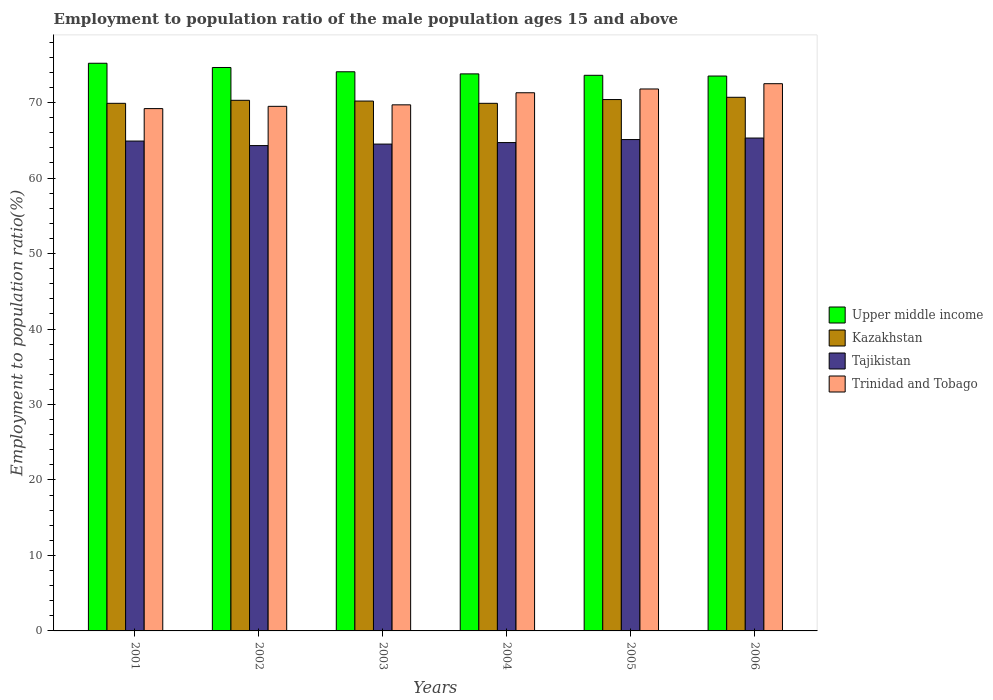How many bars are there on the 1st tick from the left?
Offer a terse response. 4. How many bars are there on the 5th tick from the right?
Your response must be concise. 4. What is the employment to population ratio in Tajikistan in 2001?
Give a very brief answer. 64.9. Across all years, what is the maximum employment to population ratio in Trinidad and Tobago?
Provide a short and direct response. 72.5. Across all years, what is the minimum employment to population ratio in Kazakhstan?
Your answer should be very brief. 69.9. What is the total employment to population ratio in Kazakhstan in the graph?
Keep it short and to the point. 421.4. What is the difference between the employment to population ratio in Upper middle income in 2002 and that in 2006?
Your response must be concise. 1.13. What is the difference between the employment to population ratio in Trinidad and Tobago in 2005 and the employment to population ratio in Upper middle income in 2001?
Ensure brevity in your answer.  -3.41. What is the average employment to population ratio in Tajikistan per year?
Your response must be concise. 64.8. In the year 2003, what is the difference between the employment to population ratio in Tajikistan and employment to population ratio in Trinidad and Tobago?
Offer a terse response. -5.2. In how many years, is the employment to population ratio in Upper middle income greater than 4 %?
Your answer should be very brief. 6. What is the ratio of the employment to population ratio in Upper middle income in 2005 to that in 2006?
Offer a terse response. 1. Is the employment to population ratio in Kazakhstan in 2004 less than that in 2006?
Offer a very short reply. Yes. What is the difference between the highest and the second highest employment to population ratio in Trinidad and Tobago?
Offer a very short reply. 0.7. What is the difference between the highest and the lowest employment to population ratio in Upper middle income?
Keep it short and to the point. 1.69. In how many years, is the employment to population ratio in Kazakhstan greater than the average employment to population ratio in Kazakhstan taken over all years?
Provide a short and direct response. 3. Is the sum of the employment to population ratio in Trinidad and Tobago in 2001 and 2004 greater than the maximum employment to population ratio in Tajikistan across all years?
Provide a short and direct response. Yes. What does the 3rd bar from the left in 2001 represents?
Your answer should be compact. Tajikistan. What does the 4th bar from the right in 2006 represents?
Make the answer very short. Upper middle income. Is it the case that in every year, the sum of the employment to population ratio in Upper middle income and employment to population ratio in Trinidad and Tobago is greater than the employment to population ratio in Kazakhstan?
Ensure brevity in your answer.  Yes. What is the difference between two consecutive major ticks on the Y-axis?
Your answer should be compact. 10. Are the values on the major ticks of Y-axis written in scientific E-notation?
Keep it short and to the point. No. Does the graph contain grids?
Provide a succinct answer. No. Where does the legend appear in the graph?
Ensure brevity in your answer.  Center right. What is the title of the graph?
Ensure brevity in your answer.  Employment to population ratio of the male population ages 15 and above. What is the label or title of the X-axis?
Provide a short and direct response. Years. What is the Employment to population ratio(%) of Upper middle income in 2001?
Provide a succinct answer. 75.21. What is the Employment to population ratio(%) in Kazakhstan in 2001?
Give a very brief answer. 69.9. What is the Employment to population ratio(%) of Tajikistan in 2001?
Make the answer very short. 64.9. What is the Employment to population ratio(%) of Trinidad and Tobago in 2001?
Offer a very short reply. 69.2. What is the Employment to population ratio(%) of Upper middle income in 2002?
Offer a terse response. 74.65. What is the Employment to population ratio(%) in Kazakhstan in 2002?
Make the answer very short. 70.3. What is the Employment to population ratio(%) of Tajikistan in 2002?
Your response must be concise. 64.3. What is the Employment to population ratio(%) of Trinidad and Tobago in 2002?
Give a very brief answer. 69.5. What is the Employment to population ratio(%) of Upper middle income in 2003?
Your response must be concise. 74.08. What is the Employment to population ratio(%) of Kazakhstan in 2003?
Your response must be concise. 70.2. What is the Employment to population ratio(%) in Tajikistan in 2003?
Make the answer very short. 64.5. What is the Employment to population ratio(%) in Trinidad and Tobago in 2003?
Your answer should be compact. 69.7. What is the Employment to population ratio(%) in Upper middle income in 2004?
Provide a short and direct response. 73.8. What is the Employment to population ratio(%) in Kazakhstan in 2004?
Your answer should be compact. 69.9. What is the Employment to population ratio(%) in Tajikistan in 2004?
Offer a terse response. 64.7. What is the Employment to population ratio(%) in Trinidad and Tobago in 2004?
Offer a terse response. 71.3. What is the Employment to population ratio(%) in Upper middle income in 2005?
Offer a very short reply. 73.61. What is the Employment to population ratio(%) of Kazakhstan in 2005?
Keep it short and to the point. 70.4. What is the Employment to population ratio(%) of Tajikistan in 2005?
Your answer should be compact. 65.1. What is the Employment to population ratio(%) in Trinidad and Tobago in 2005?
Provide a succinct answer. 71.8. What is the Employment to population ratio(%) in Upper middle income in 2006?
Ensure brevity in your answer.  73.51. What is the Employment to population ratio(%) in Kazakhstan in 2006?
Offer a terse response. 70.7. What is the Employment to population ratio(%) in Tajikistan in 2006?
Ensure brevity in your answer.  65.3. What is the Employment to population ratio(%) of Trinidad and Tobago in 2006?
Keep it short and to the point. 72.5. Across all years, what is the maximum Employment to population ratio(%) in Upper middle income?
Provide a short and direct response. 75.21. Across all years, what is the maximum Employment to population ratio(%) in Kazakhstan?
Keep it short and to the point. 70.7. Across all years, what is the maximum Employment to population ratio(%) in Tajikistan?
Your answer should be compact. 65.3. Across all years, what is the maximum Employment to population ratio(%) of Trinidad and Tobago?
Offer a very short reply. 72.5. Across all years, what is the minimum Employment to population ratio(%) in Upper middle income?
Offer a terse response. 73.51. Across all years, what is the minimum Employment to population ratio(%) of Kazakhstan?
Make the answer very short. 69.9. Across all years, what is the minimum Employment to population ratio(%) of Tajikistan?
Your response must be concise. 64.3. Across all years, what is the minimum Employment to population ratio(%) in Trinidad and Tobago?
Provide a short and direct response. 69.2. What is the total Employment to population ratio(%) of Upper middle income in the graph?
Provide a short and direct response. 444.86. What is the total Employment to population ratio(%) in Kazakhstan in the graph?
Make the answer very short. 421.4. What is the total Employment to population ratio(%) of Tajikistan in the graph?
Keep it short and to the point. 388.8. What is the total Employment to population ratio(%) in Trinidad and Tobago in the graph?
Offer a terse response. 424. What is the difference between the Employment to population ratio(%) of Upper middle income in 2001 and that in 2002?
Your answer should be very brief. 0.56. What is the difference between the Employment to population ratio(%) of Kazakhstan in 2001 and that in 2002?
Ensure brevity in your answer.  -0.4. What is the difference between the Employment to population ratio(%) in Trinidad and Tobago in 2001 and that in 2002?
Give a very brief answer. -0.3. What is the difference between the Employment to population ratio(%) in Upper middle income in 2001 and that in 2003?
Offer a very short reply. 1.13. What is the difference between the Employment to population ratio(%) of Trinidad and Tobago in 2001 and that in 2003?
Your answer should be compact. -0.5. What is the difference between the Employment to population ratio(%) in Upper middle income in 2001 and that in 2004?
Make the answer very short. 1.41. What is the difference between the Employment to population ratio(%) of Tajikistan in 2001 and that in 2004?
Offer a terse response. 0.2. What is the difference between the Employment to population ratio(%) in Upper middle income in 2001 and that in 2005?
Provide a succinct answer. 1.6. What is the difference between the Employment to population ratio(%) in Trinidad and Tobago in 2001 and that in 2005?
Offer a very short reply. -2.6. What is the difference between the Employment to population ratio(%) of Upper middle income in 2001 and that in 2006?
Your answer should be compact. 1.69. What is the difference between the Employment to population ratio(%) of Kazakhstan in 2001 and that in 2006?
Keep it short and to the point. -0.8. What is the difference between the Employment to population ratio(%) in Tajikistan in 2001 and that in 2006?
Ensure brevity in your answer.  -0.4. What is the difference between the Employment to population ratio(%) of Upper middle income in 2002 and that in 2003?
Give a very brief answer. 0.57. What is the difference between the Employment to population ratio(%) in Tajikistan in 2002 and that in 2003?
Provide a short and direct response. -0.2. What is the difference between the Employment to population ratio(%) of Trinidad and Tobago in 2002 and that in 2003?
Provide a short and direct response. -0.2. What is the difference between the Employment to population ratio(%) in Upper middle income in 2002 and that in 2004?
Your response must be concise. 0.85. What is the difference between the Employment to population ratio(%) of Kazakhstan in 2002 and that in 2004?
Make the answer very short. 0.4. What is the difference between the Employment to population ratio(%) of Tajikistan in 2002 and that in 2004?
Your answer should be compact. -0.4. What is the difference between the Employment to population ratio(%) of Upper middle income in 2002 and that in 2005?
Offer a terse response. 1.04. What is the difference between the Employment to population ratio(%) of Kazakhstan in 2002 and that in 2005?
Your answer should be very brief. -0.1. What is the difference between the Employment to population ratio(%) in Upper middle income in 2002 and that in 2006?
Make the answer very short. 1.13. What is the difference between the Employment to population ratio(%) in Kazakhstan in 2002 and that in 2006?
Keep it short and to the point. -0.4. What is the difference between the Employment to population ratio(%) of Tajikistan in 2002 and that in 2006?
Make the answer very short. -1. What is the difference between the Employment to population ratio(%) in Upper middle income in 2003 and that in 2004?
Your answer should be compact. 0.28. What is the difference between the Employment to population ratio(%) of Trinidad and Tobago in 2003 and that in 2004?
Your answer should be compact. -1.6. What is the difference between the Employment to population ratio(%) of Upper middle income in 2003 and that in 2005?
Give a very brief answer. 0.47. What is the difference between the Employment to population ratio(%) in Tajikistan in 2003 and that in 2005?
Provide a succinct answer. -0.6. What is the difference between the Employment to population ratio(%) of Trinidad and Tobago in 2003 and that in 2005?
Offer a very short reply. -2.1. What is the difference between the Employment to population ratio(%) of Upper middle income in 2003 and that in 2006?
Make the answer very short. 0.56. What is the difference between the Employment to population ratio(%) in Kazakhstan in 2003 and that in 2006?
Provide a short and direct response. -0.5. What is the difference between the Employment to population ratio(%) in Tajikistan in 2003 and that in 2006?
Your answer should be compact. -0.8. What is the difference between the Employment to population ratio(%) in Upper middle income in 2004 and that in 2005?
Keep it short and to the point. 0.19. What is the difference between the Employment to population ratio(%) of Trinidad and Tobago in 2004 and that in 2005?
Provide a succinct answer. -0.5. What is the difference between the Employment to population ratio(%) in Upper middle income in 2004 and that in 2006?
Provide a succinct answer. 0.28. What is the difference between the Employment to population ratio(%) of Upper middle income in 2005 and that in 2006?
Provide a succinct answer. 0.1. What is the difference between the Employment to population ratio(%) in Upper middle income in 2001 and the Employment to population ratio(%) in Kazakhstan in 2002?
Offer a terse response. 4.91. What is the difference between the Employment to population ratio(%) of Upper middle income in 2001 and the Employment to population ratio(%) of Tajikistan in 2002?
Offer a terse response. 10.91. What is the difference between the Employment to population ratio(%) in Upper middle income in 2001 and the Employment to population ratio(%) in Trinidad and Tobago in 2002?
Your response must be concise. 5.71. What is the difference between the Employment to population ratio(%) in Kazakhstan in 2001 and the Employment to population ratio(%) in Tajikistan in 2002?
Keep it short and to the point. 5.6. What is the difference between the Employment to population ratio(%) in Upper middle income in 2001 and the Employment to population ratio(%) in Kazakhstan in 2003?
Offer a terse response. 5.01. What is the difference between the Employment to population ratio(%) in Upper middle income in 2001 and the Employment to population ratio(%) in Tajikistan in 2003?
Your answer should be very brief. 10.71. What is the difference between the Employment to population ratio(%) of Upper middle income in 2001 and the Employment to population ratio(%) of Trinidad and Tobago in 2003?
Your answer should be compact. 5.51. What is the difference between the Employment to population ratio(%) in Kazakhstan in 2001 and the Employment to population ratio(%) in Tajikistan in 2003?
Your answer should be compact. 5.4. What is the difference between the Employment to population ratio(%) of Kazakhstan in 2001 and the Employment to population ratio(%) of Trinidad and Tobago in 2003?
Give a very brief answer. 0.2. What is the difference between the Employment to population ratio(%) in Upper middle income in 2001 and the Employment to population ratio(%) in Kazakhstan in 2004?
Provide a short and direct response. 5.31. What is the difference between the Employment to population ratio(%) of Upper middle income in 2001 and the Employment to population ratio(%) of Tajikistan in 2004?
Give a very brief answer. 10.51. What is the difference between the Employment to population ratio(%) of Upper middle income in 2001 and the Employment to population ratio(%) of Trinidad and Tobago in 2004?
Provide a succinct answer. 3.91. What is the difference between the Employment to population ratio(%) in Kazakhstan in 2001 and the Employment to population ratio(%) in Tajikistan in 2004?
Ensure brevity in your answer.  5.2. What is the difference between the Employment to population ratio(%) in Kazakhstan in 2001 and the Employment to population ratio(%) in Trinidad and Tobago in 2004?
Make the answer very short. -1.4. What is the difference between the Employment to population ratio(%) of Tajikistan in 2001 and the Employment to population ratio(%) of Trinidad and Tobago in 2004?
Make the answer very short. -6.4. What is the difference between the Employment to population ratio(%) of Upper middle income in 2001 and the Employment to population ratio(%) of Kazakhstan in 2005?
Provide a succinct answer. 4.81. What is the difference between the Employment to population ratio(%) in Upper middle income in 2001 and the Employment to population ratio(%) in Tajikistan in 2005?
Offer a very short reply. 10.11. What is the difference between the Employment to population ratio(%) of Upper middle income in 2001 and the Employment to population ratio(%) of Trinidad and Tobago in 2005?
Your answer should be very brief. 3.41. What is the difference between the Employment to population ratio(%) in Kazakhstan in 2001 and the Employment to population ratio(%) in Tajikistan in 2005?
Give a very brief answer. 4.8. What is the difference between the Employment to population ratio(%) in Kazakhstan in 2001 and the Employment to population ratio(%) in Trinidad and Tobago in 2005?
Make the answer very short. -1.9. What is the difference between the Employment to population ratio(%) in Tajikistan in 2001 and the Employment to population ratio(%) in Trinidad and Tobago in 2005?
Your response must be concise. -6.9. What is the difference between the Employment to population ratio(%) in Upper middle income in 2001 and the Employment to population ratio(%) in Kazakhstan in 2006?
Offer a terse response. 4.51. What is the difference between the Employment to population ratio(%) in Upper middle income in 2001 and the Employment to population ratio(%) in Tajikistan in 2006?
Give a very brief answer. 9.91. What is the difference between the Employment to population ratio(%) in Upper middle income in 2001 and the Employment to population ratio(%) in Trinidad and Tobago in 2006?
Provide a short and direct response. 2.71. What is the difference between the Employment to population ratio(%) of Upper middle income in 2002 and the Employment to population ratio(%) of Kazakhstan in 2003?
Offer a very short reply. 4.45. What is the difference between the Employment to population ratio(%) of Upper middle income in 2002 and the Employment to population ratio(%) of Tajikistan in 2003?
Your answer should be compact. 10.15. What is the difference between the Employment to population ratio(%) of Upper middle income in 2002 and the Employment to population ratio(%) of Trinidad and Tobago in 2003?
Give a very brief answer. 4.95. What is the difference between the Employment to population ratio(%) of Kazakhstan in 2002 and the Employment to population ratio(%) of Tajikistan in 2003?
Keep it short and to the point. 5.8. What is the difference between the Employment to population ratio(%) of Kazakhstan in 2002 and the Employment to population ratio(%) of Trinidad and Tobago in 2003?
Offer a very short reply. 0.6. What is the difference between the Employment to population ratio(%) of Upper middle income in 2002 and the Employment to population ratio(%) of Kazakhstan in 2004?
Your answer should be compact. 4.75. What is the difference between the Employment to population ratio(%) in Upper middle income in 2002 and the Employment to population ratio(%) in Tajikistan in 2004?
Provide a short and direct response. 9.95. What is the difference between the Employment to population ratio(%) of Upper middle income in 2002 and the Employment to population ratio(%) of Trinidad and Tobago in 2004?
Offer a very short reply. 3.35. What is the difference between the Employment to population ratio(%) of Kazakhstan in 2002 and the Employment to population ratio(%) of Tajikistan in 2004?
Offer a very short reply. 5.6. What is the difference between the Employment to population ratio(%) in Kazakhstan in 2002 and the Employment to population ratio(%) in Trinidad and Tobago in 2004?
Give a very brief answer. -1. What is the difference between the Employment to population ratio(%) in Tajikistan in 2002 and the Employment to population ratio(%) in Trinidad and Tobago in 2004?
Make the answer very short. -7. What is the difference between the Employment to population ratio(%) in Upper middle income in 2002 and the Employment to population ratio(%) in Kazakhstan in 2005?
Your response must be concise. 4.25. What is the difference between the Employment to population ratio(%) of Upper middle income in 2002 and the Employment to population ratio(%) of Tajikistan in 2005?
Keep it short and to the point. 9.55. What is the difference between the Employment to population ratio(%) of Upper middle income in 2002 and the Employment to population ratio(%) of Trinidad and Tobago in 2005?
Keep it short and to the point. 2.85. What is the difference between the Employment to population ratio(%) of Tajikistan in 2002 and the Employment to population ratio(%) of Trinidad and Tobago in 2005?
Offer a terse response. -7.5. What is the difference between the Employment to population ratio(%) in Upper middle income in 2002 and the Employment to population ratio(%) in Kazakhstan in 2006?
Ensure brevity in your answer.  3.95. What is the difference between the Employment to population ratio(%) of Upper middle income in 2002 and the Employment to population ratio(%) of Tajikistan in 2006?
Your response must be concise. 9.35. What is the difference between the Employment to population ratio(%) of Upper middle income in 2002 and the Employment to population ratio(%) of Trinidad and Tobago in 2006?
Provide a short and direct response. 2.15. What is the difference between the Employment to population ratio(%) of Kazakhstan in 2002 and the Employment to population ratio(%) of Tajikistan in 2006?
Give a very brief answer. 5. What is the difference between the Employment to population ratio(%) of Kazakhstan in 2002 and the Employment to population ratio(%) of Trinidad and Tobago in 2006?
Your answer should be very brief. -2.2. What is the difference between the Employment to population ratio(%) of Upper middle income in 2003 and the Employment to population ratio(%) of Kazakhstan in 2004?
Ensure brevity in your answer.  4.18. What is the difference between the Employment to population ratio(%) in Upper middle income in 2003 and the Employment to population ratio(%) in Tajikistan in 2004?
Your response must be concise. 9.38. What is the difference between the Employment to population ratio(%) in Upper middle income in 2003 and the Employment to population ratio(%) in Trinidad and Tobago in 2004?
Your answer should be compact. 2.78. What is the difference between the Employment to population ratio(%) of Upper middle income in 2003 and the Employment to population ratio(%) of Kazakhstan in 2005?
Ensure brevity in your answer.  3.68. What is the difference between the Employment to population ratio(%) in Upper middle income in 2003 and the Employment to population ratio(%) in Tajikistan in 2005?
Ensure brevity in your answer.  8.98. What is the difference between the Employment to population ratio(%) in Upper middle income in 2003 and the Employment to population ratio(%) in Trinidad and Tobago in 2005?
Your answer should be very brief. 2.28. What is the difference between the Employment to population ratio(%) of Upper middle income in 2003 and the Employment to population ratio(%) of Kazakhstan in 2006?
Your response must be concise. 3.38. What is the difference between the Employment to population ratio(%) of Upper middle income in 2003 and the Employment to population ratio(%) of Tajikistan in 2006?
Offer a very short reply. 8.78. What is the difference between the Employment to population ratio(%) of Upper middle income in 2003 and the Employment to population ratio(%) of Trinidad and Tobago in 2006?
Your response must be concise. 1.58. What is the difference between the Employment to population ratio(%) of Kazakhstan in 2003 and the Employment to population ratio(%) of Tajikistan in 2006?
Keep it short and to the point. 4.9. What is the difference between the Employment to population ratio(%) of Upper middle income in 2004 and the Employment to population ratio(%) of Kazakhstan in 2005?
Your response must be concise. 3.4. What is the difference between the Employment to population ratio(%) in Upper middle income in 2004 and the Employment to population ratio(%) in Tajikistan in 2005?
Your answer should be compact. 8.7. What is the difference between the Employment to population ratio(%) of Upper middle income in 2004 and the Employment to population ratio(%) of Trinidad and Tobago in 2005?
Provide a succinct answer. 2. What is the difference between the Employment to population ratio(%) in Kazakhstan in 2004 and the Employment to population ratio(%) in Trinidad and Tobago in 2005?
Ensure brevity in your answer.  -1.9. What is the difference between the Employment to population ratio(%) of Tajikistan in 2004 and the Employment to population ratio(%) of Trinidad and Tobago in 2005?
Your answer should be compact. -7.1. What is the difference between the Employment to population ratio(%) in Upper middle income in 2004 and the Employment to population ratio(%) in Kazakhstan in 2006?
Provide a short and direct response. 3.1. What is the difference between the Employment to population ratio(%) in Upper middle income in 2004 and the Employment to population ratio(%) in Tajikistan in 2006?
Ensure brevity in your answer.  8.5. What is the difference between the Employment to population ratio(%) of Upper middle income in 2004 and the Employment to population ratio(%) of Trinidad and Tobago in 2006?
Keep it short and to the point. 1.3. What is the difference between the Employment to population ratio(%) of Tajikistan in 2004 and the Employment to population ratio(%) of Trinidad and Tobago in 2006?
Offer a very short reply. -7.8. What is the difference between the Employment to population ratio(%) in Upper middle income in 2005 and the Employment to population ratio(%) in Kazakhstan in 2006?
Keep it short and to the point. 2.91. What is the difference between the Employment to population ratio(%) of Upper middle income in 2005 and the Employment to population ratio(%) of Tajikistan in 2006?
Ensure brevity in your answer.  8.31. What is the difference between the Employment to population ratio(%) in Upper middle income in 2005 and the Employment to population ratio(%) in Trinidad and Tobago in 2006?
Keep it short and to the point. 1.11. What is the difference between the Employment to population ratio(%) of Kazakhstan in 2005 and the Employment to population ratio(%) of Tajikistan in 2006?
Give a very brief answer. 5.1. What is the difference between the Employment to population ratio(%) of Tajikistan in 2005 and the Employment to population ratio(%) of Trinidad and Tobago in 2006?
Your response must be concise. -7.4. What is the average Employment to population ratio(%) in Upper middle income per year?
Offer a terse response. 74.14. What is the average Employment to population ratio(%) in Kazakhstan per year?
Offer a very short reply. 70.23. What is the average Employment to population ratio(%) of Tajikistan per year?
Ensure brevity in your answer.  64.8. What is the average Employment to population ratio(%) of Trinidad and Tobago per year?
Your answer should be very brief. 70.67. In the year 2001, what is the difference between the Employment to population ratio(%) in Upper middle income and Employment to population ratio(%) in Kazakhstan?
Provide a succinct answer. 5.31. In the year 2001, what is the difference between the Employment to population ratio(%) of Upper middle income and Employment to population ratio(%) of Tajikistan?
Provide a succinct answer. 10.31. In the year 2001, what is the difference between the Employment to population ratio(%) in Upper middle income and Employment to population ratio(%) in Trinidad and Tobago?
Give a very brief answer. 6.01. In the year 2001, what is the difference between the Employment to population ratio(%) in Kazakhstan and Employment to population ratio(%) in Tajikistan?
Provide a short and direct response. 5. In the year 2001, what is the difference between the Employment to population ratio(%) in Kazakhstan and Employment to population ratio(%) in Trinidad and Tobago?
Ensure brevity in your answer.  0.7. In the year 2001, what is the difference between the Employment to population ratio(%) of Tajikistan and Employment to population ratio(%) of Trinidad and Tobago?
Provide a short and direct response. -4.3. In the year 2002, what is the difference between the Employment to population ratio(%) in Upper middle income and Employment to population ratio(%) in Kazakhstan?
Give a very brief answer. 4.35. In the year 2002, what is the difference between the Employment to population ratio(%) of Upper middle income and Employment to population ratio(%) of Tajikistan?
Keep it short and to the point. 10.35. In the year 2002, what is the difference between the Employment to population ratio(%) in Upper middle income and Employment to population ratio(%) in Trinidad and Tobago?
Provide a short and direct response. 5.15. In the year 2002, what is the difference between the Employment to population ratio(%) of Kazakhstan and Employment to population ratio(%) of Tajikistan?
Ensure brevity in your answer.  6. In the year 2002, what is the difference between the Employment to population ratio(%) of Kazakhstan and Employment to population ratio(%) of Trinidad and Tobago?
Your response must be concise. 0.8. In the year 2002, what is the difference between the Employment to population ratio(%) of Tajikistan and Employment to population ratio(%) of Trinidad and Tobago?
Your answer should be compact. -5.2. In the year 2003, what is the difference between the Employment to population ratio(%) of Upper middle income and Employment to population ratio(%) of Kazakhstan?
Offer a very short reply. 3.88. In the year 2003, what is the difference between the Employment to population ratio(%) in Upper middle income and Employment to population ratio(%) in Tajikistan?
Keep it short and to the point. 9.58. In the year 2003, what is the difference between the Employment to population ratio(%) in Upper middle income and Employment to population ratio(%) in Trinidad and Tobago?
Provide a short and direct response. 4.38. In the year 2003, what is the difference between the Employment to population ratio(%) in Kazakhstan and Employment to population ratio(%) in Tajikistan?
Offer a very short reply. 5.7. In the year 2003, what is the difference between the Employment to population ratio(%) in Kazakhstan and Employment to population ratio(%) in Trinidad and Tobago?
Keep it short and to the point. 0.5. In the year 2004, what is the difference between the Employment to population ratio(%) in Upper middle income and Employment to population ratio(%) in Kazakhstan?
Make the answer very short. 3.9. In the year 2004, what is the difference between the Employment to population ratio(%) of Upper middle income and Employment to population ratio(%) of Tajikistan?
Your response must be concise. 9.1. In the year 2004, what is the difference between the Employment to population ratio(%) of Upper middle income and Employment to population ratio(%) of Trinidad and Tobago?
Ensure brevity in your answer.  2.5. In the year 2004, what is the difference between the Employment to population ratio(%) of Kazakhstan and Employment to population ratio(%) of Tajikistan?
Provide a succinct answer. 5.2. In the year 2004, what is the difference between the Employment to population ratio(%) in Kazakhstan and Employment to population ratio(%) in Trinidad and Tobago?
Ensure brevity in your answer.  -1.4. In the year 2005, what is the difference between the Employment to population ratio(%) of Upper middle income and Employment to population ratio(%) of Kazakhstan?
Ensure brevity in your answer.  3.21. In the year 2005, what is the difference between the Employment to population ratio(%) of Upper middle income and Employment to population ratio(%) of Tajikistan?
Your answer should be compact. 8.51. In the year 2005, what is the difference between the Employment to population ratio(%) in Upper middle income and Employment to population ratio(%) in Trinidad and Tobago?
Offer a terse response. 1.81. In the year 2005, what is the difference between the Employment to population ratio(%) of Kazakhstan and Employment to population ratio(%) of Tajikistan?
Give a very brief answer. 5.3. In the year 2005, what is the difference between the Employment to population ratio(%) of Tajikistan and Employment to population ratio(%) of Trinidad and Tobago?
Offer a very short reply. -6.7. In the year 2006, what is the difference between the Employment to population ratio(%) in Upper middle income and Employment to population ratio(%) in Kazakhstan?
Provide a short and direct response. 2.81. In the year 2006, what is the difference between the Employment to population ratio(%) of Upper middle income and Employment to population ratio(%) of Tajikistan?
Make the answer very short. 8.21. In the year 2006, what is the difference between the Employment to population ratio(%) of Upper middle income and Employment to population ratio(%) of Trinidad and Tobago?
Offer a very short reply. 1.01. In the year 2006, what is the difference between the Employment to population ratio(%) in Kazakhstan and Employment to population ratio(%) in Trinidad and Tobago?
Your answer should be compact. -1.8. What is the ratio of the Employment to population ratio(%) in Upper middle income in 2001 to that in 2002?
Ensure brevity in your answer.  1.01. What is the ratio of the Employment to population ratio(%) in Tajikistan in 2001 to that in 2002?
Give a very brief answer. 1.01. What is the ratio of the Employment to population ratio(%) in Trinidad and Tobago in 2001 to that in 2002?
Your answer should be compact. 1. What is the ratio of the Employment to population ratio(%) in Upper middle income in 2001 to that in 2003?
Make the answer very short. 1.02. What is the ratio of the Employment to population ratio(%) in Kazakhstan in 2001 to that in 2003?
Give a very brief answer. 1. What is the ratio of the Employment to population ratio(%) in Tajikistan in 2001 to that in 2003?
Give a very brief answer. 1.01. What is the ratio of the Employment to population ratio(%) in Trinidad and Tobago in 2001 to that in 2003?
Your answer should be compact. 0.99. What is the ratio of the Employment to population ratio(%) in Upper middle income in 2001 to that in 2004?
Make the answer very short. 1.02. What is the ratio of the Employment to population ratio(%) of Kazakhstan in 2001 to that in 2004?
Your response must be concise. 1. What is the ratio of the Employment to population ratio(%) of Trinidad and Tobago in 2001 to that in 2004?
Offer a terse response. 0.97. What is the ratio of the Employment to population ratio(%) of Upper middle income in 2001 to that in 2005?
Provide a succinct answer. 1.02. What is the ratio of the Employment to population ratio(%) of Trinidad and Tobago in 2001 to that in 2005?
Ensure brevity in your answer.  0.96. What is the ratio of the Employment to population ratio(%) in Kazakhstan in 2001 to that in 2006?
Your answer should be very brief. 0.99. What is the ratio of the Employment to population ratio(%) of Trinidad and Tobago in 2001 to that in 2006?
Provide a short and direct response. 0.95. What is the ratio of the Employment to population ratio(%) of Upper middle income in 2002 to that in 2003?
Your answer should be very brief. 1.01. What is the ratio of the Employment to population ratio(%) in Tajikistan in 2002 to that in 2003?
Provide a short and direct response. 1. What is the ratio of the Employment to population ratio(%) in Upper middle income in 2002 to that in 2004?
Make the answer very short. 1.01. What is the ratio of the Employment to population ratio(%) of Kazakhstan in 2002 to that in 2004?
Make the answer very short. 1.01. What is the ratio of the Employment to population ratio(%) in Trinidad and Tobago in 2002 to that in 2004?
Make the answer very short. 0.97. What is the ratio of the Employment to population ratio(%) of Upper middle income in 2002 to that in 2005?
Your answer should be compact. 1.01. What is the ratio of the Employment to population ratio(%) of Trinidad and Tobago in 2002 to that in 2005?
Your response must be concise. 0.97. What is the ratio of the Employment to population ratio(%) in Upper middle income in 2002 to that in 2006?
Keep it short and to the point. 1.02. What is the ratio of the Employment to population ratio(%) in Kazakhstan in 2002 to that in 2006?
Keep it short and to the point. 0.99. What is the ratio of the Employment to population ratio(%) in Tajikistan in 2002 to that in 2006?
Ensure brevity in your answer.  0.98. What is the ratio of the Employment to population ratio(%) in Trinidad and Tobago in 2002 to that in 2006?
Ensure brevity in your answer.  0.96. What is the ratio of the Employment to population ratio(%) in Upper middle income in 2003 to that in 2004?
Make the answer very short. 1. What is the ratio of the Employment to population ratio(%) in Trinidad and Tobago in 2003 to that in 2004?
Offer a very short reply. 0.98. What is the ratio of the Employment to population ratio(%) in Upper middle income in 2003 to that in 2005?
Your answer should be compact. 1.01. What is the ratio of the Employment to population ratio(%) in Tajikistan in 2003 to that in 2005?
Give a very brief answer. 0.99. What is the ratio of the Employment to population ratio(%) in Trinidad and Tobago in 2003 to that in 2005?
Your answer should be very brief. 0.97. What is the ratio of the Employment to population ratio(%) of Upper middle income in 2003 to that in 2006?
Your response must be concise. 1.01. What is the ratio of the Employment to population ratio(%) of Tajikistan in 2003 to that in 2006?
Your response must be concise. 0.99. What is the ratio of the Employment to population ratio(%) in Trinidad and Tobago in 2003 to that in 2006?
Your answer should be very brief. 0.96. What is the ratio of the Employment to population ratio(%) in Kazakhstan in 2004 to that in 2006?
Your answer should be compact. 0.99. What is the ratio of the Employment to population ratio(%) of Tajikistan in 2004 to that in 2006?
Your response must be concise. 0.99. What is the ratio of the Employment to population ratio(%) in Trinidad and Tobago in 2004 to that in 2006?
Ensure brevity in your answer.  0.98. What is the ratio of the Employment to population ratio(%) of Kazakhstan in 2005 to that in 2006?
Ensure brevity in your answer.  1. What is the ratio of the Employment to population ratio(%) of Trinidad and Tobago in 2005 to that in 2006?
Your response must be concise. 0.99. What is the difference between the highest and the second highest Employment to population ratio(%) of Upper middle income?
Make the answer very short. 0.56. What is the difference between the highest and the second highest Employment to population ratio(%) of Trinidad and Tobago?
Your response must be concise. 0.7. What is the difference between the highest and the lowest Employment to population ratio(%) in Upper middle income?
Make the answer very short. 1.69. What is the difference between the highest and the lowest Employment to population ratio(%) in Trinidad and Tobago?
Your response must be concise. 3.3. 